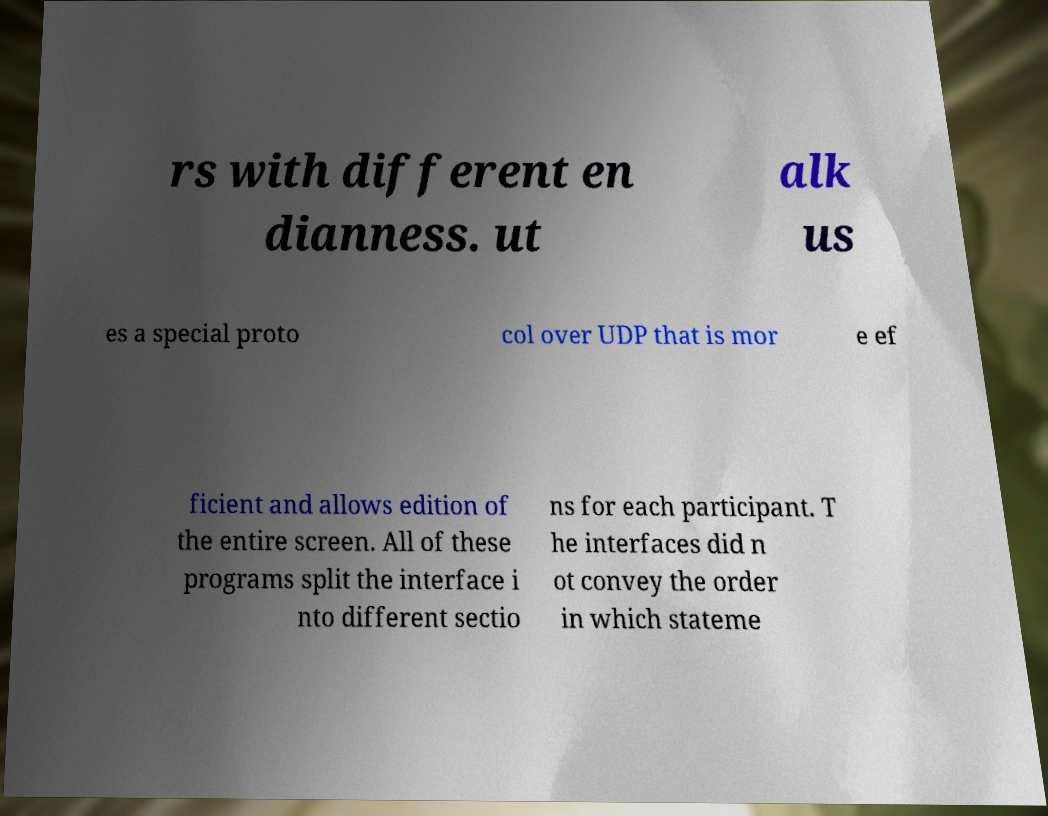I need the written content from this picture converted into text. Can you do that? rs with different en dianness. ut alk us es a special proto col over UDP that is mor e ef ficient and allows edition of the entire screen. All of these programs split the interface i nto different sectio ns for each participant. T he interfaces did n ot convey the order in which stateme 